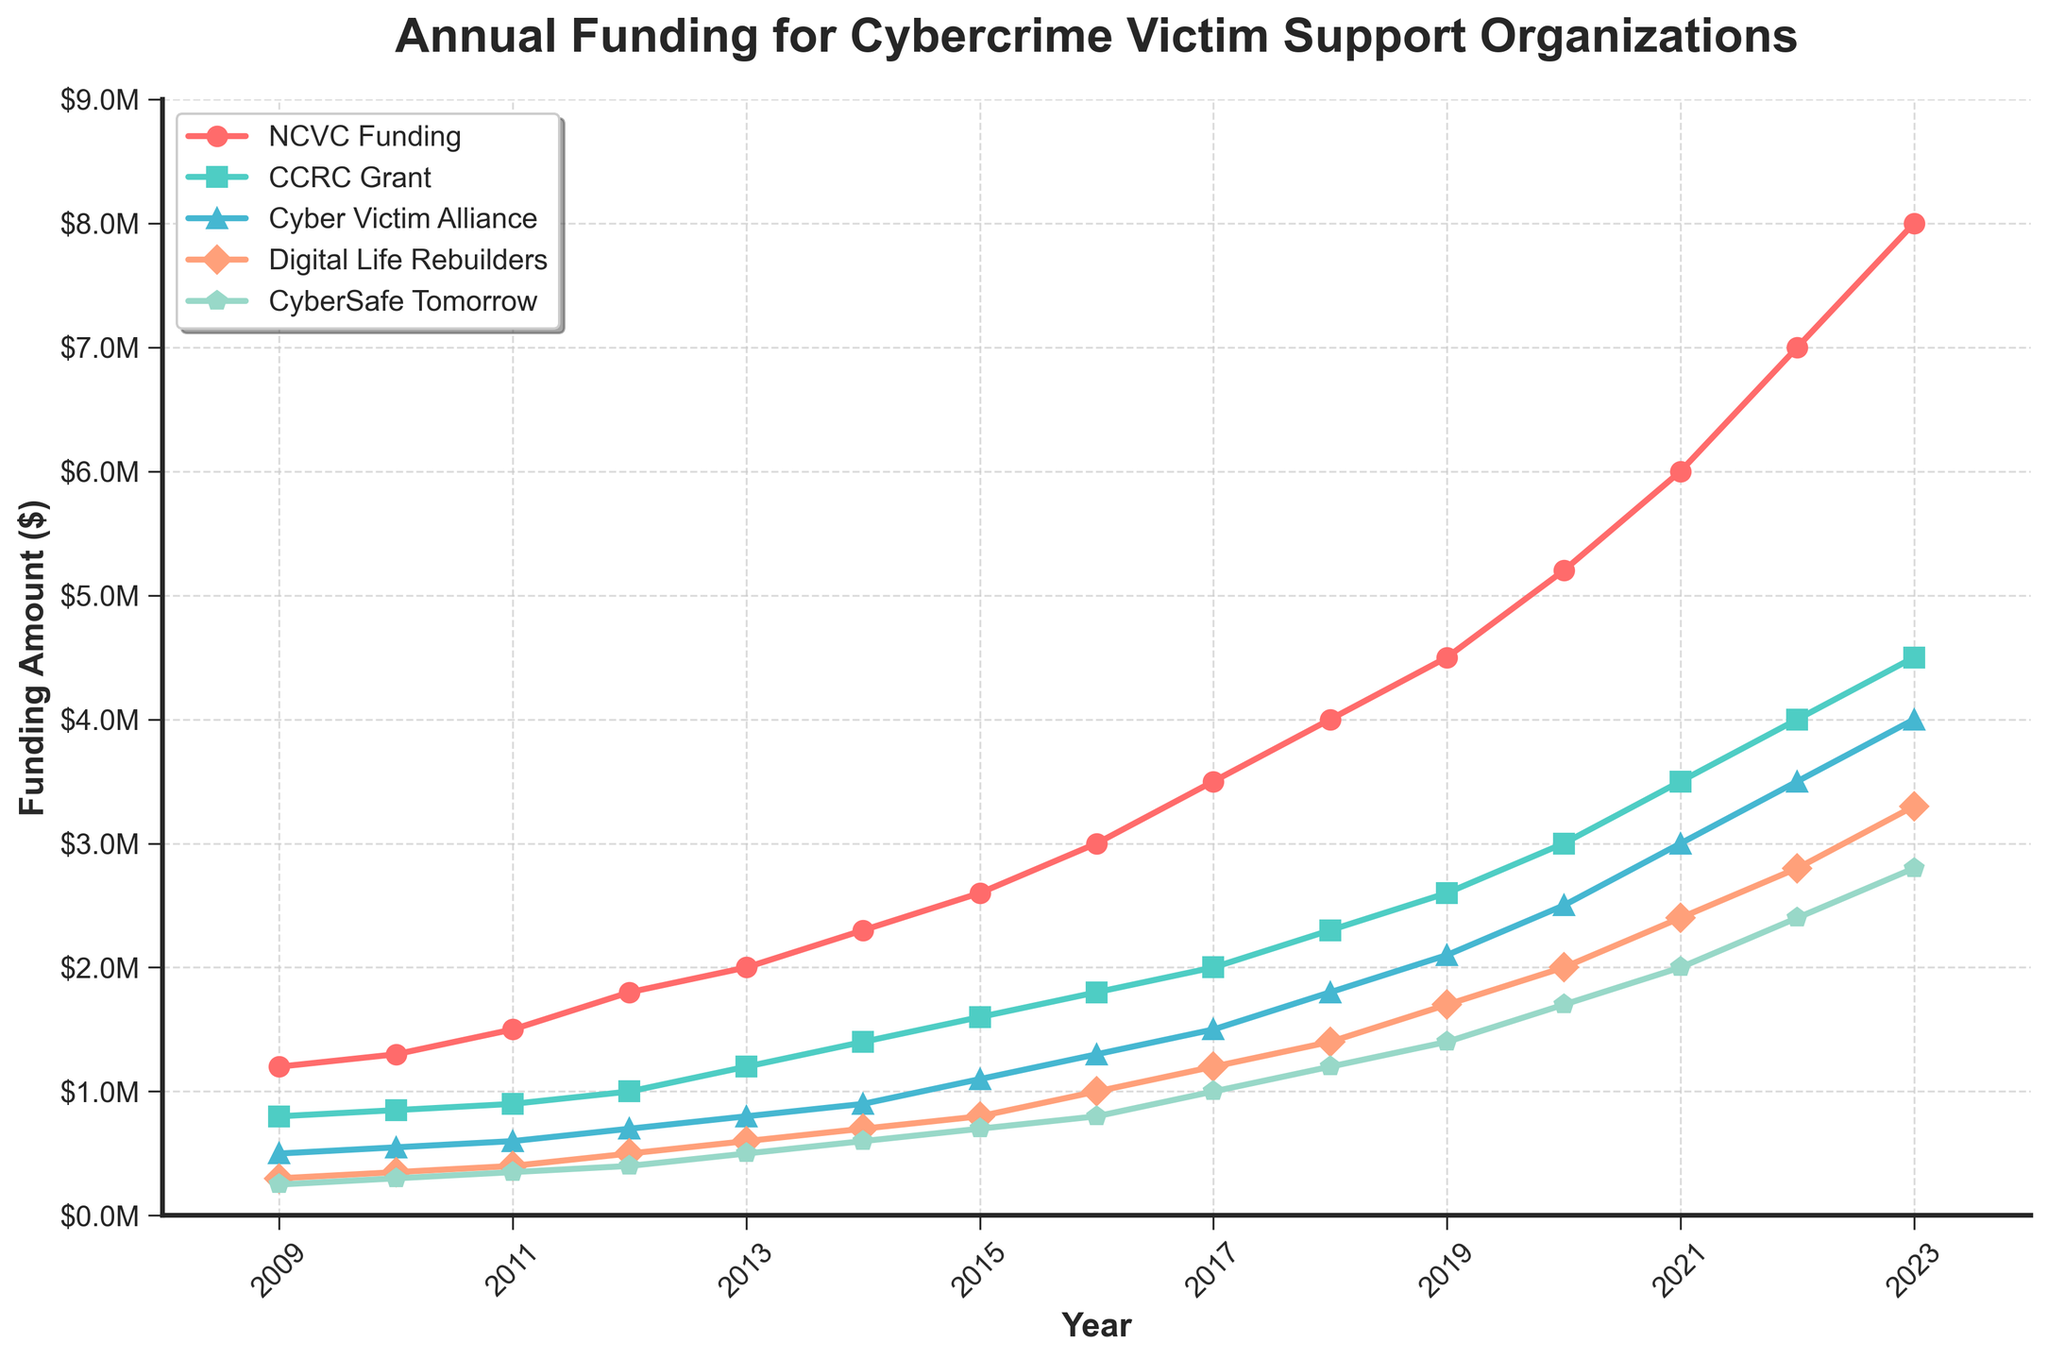What is the trend in NCVC Funding over the 15 years? The line chart shows that NCVC Funding has steadily increased from $1,200,000 in 2009 to $8,000,000 in 2023. By looking at each year's data point for NCVC Funding, a clear upward trend is visible.
Answer: Steady increase Which organization received the highest funding in 2017? By comparing the data points for 2017, NCVC Funding ($3,500,000) is higher than CCRC Grant ($2,000,000), Cyber Victim Alliance ($1,500,000), Digital Life Rebuilders ($1,200,000), and CyberSafe Tomorrow ($1,000,000). Thus, NCVC Funding received the highest funding in 2017.
Answer: NCVC Funding In which year did Digital Life Rebuilders first exceed $1,000,000 in funding? Tracking the data points for Digital Life Rebuilders across each year, it reached exactly $1,000,000 in 2016. Before that, its funding never crossed $1,000,000.
Answer: 2016 How much did CCRC Grant funding increase from 2009 to 2023? Subtracting the CCRC Grant funding in 2009 ($800,000) from the funding in 2023 ($4,500,000), we get $4,500,000 - $800,000 = $3,700,000.
Answer: $3,700,000 Which two organizations have the closest funding amounts in 2021? Looking at the funding amounts in 2021, Cyber Victim Alliance ($3,000,000) and Digital Life Rebuilders ($2,400,000) are the closest to each other. Other organizations have larger differences between their funding amounts.
Answer: Cyber Victim Alliance and Digital Life Rebuilders What is the average funding amount for CyberSafe Tomorrow over the years 2009-2023? The sum of CyberSafe Tomorrow's funding from 2009 to 2023 is: $250,000 + $300,000 + $350,000 + $400,000 + $500,000 + $600,000 + $700,000 + $800,000 + $1,000,000 + $1,200,000 + $1,400,000 + $1,700,000 + $2,000,000 + $2,400,000 + $2,800,000 = $16,000,000. There are 15 years, so the average is $16,000,000 / 15 = $1,066,667.
Answer: $1,066,667 Which organization experienced the largest percentage increase in funding from 2012 to 2017? For each organization, compute the percentage increase from 2012 to 2017: 
- NCVC Funding: (($3,500,000 - $1,800,000) / $1,800,000) * 100 ≈ 94.4%
- CCRC Grant: (($2,000,000 - $1,000,000) / $1,000,000) * 100 ≈ 100%
- Cyber Victim Alliance: (($1,500,000 - $700,000) / $700,000) * 100 ≈ 114.3%
- Digital Life Rebuilders: (($1,200,000 - $500,000) / $500,000) * 100 ≈ 140%
- CyberSafe Tomorrow: (($1,000,000 - $400,000) / $400,000) * 100 ≈ 150%
Comparing these, CyberSafe Tomorrow had the largest percentage increase.
Answer: CyberSafe Tomorrow Who has the steadiest increase in funding over the period? Among all considered organizations, NCVC Funding shows a consistent and steady increasing line across all years, without large jumps or fluctuations.
Answer: NCVC Funding In which year did Cyber Victim Alliance surpass $2,000,000 in funding? By examining the data points for Cyber Victim Alliance, it surpasses $2,000,000 in 2019.
Answer: 2019 What is the combined funding for all five organizations in 2015? Summing up the funding amounts for all organizations in 2015, we get: $2,600,000 (NCVC Funding) + $1,600,000 (CCRC Grant) + $1,100,000 (Cyber Victim Alliance) + $800,000 (Digital Life Rebuilders) + $700,000 (CyberSafe Tomorrow) = $6,800,000.
Answer: $6,800,000 